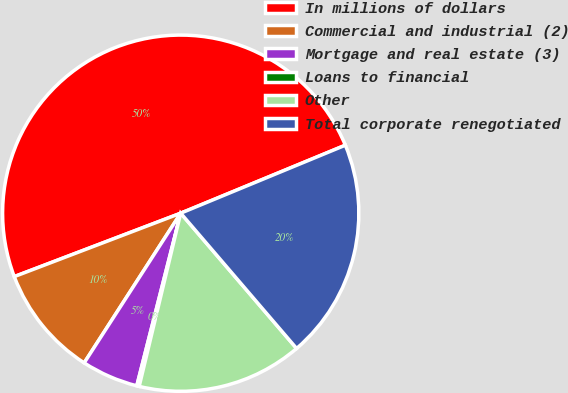Convert chart to OTSL. <chart><loc_0><loc_0><loc_500><loc_500><pie_chart><fcel>In millions of dollars<fcel>Commercial and industrial (2)<fcel>Mortgage and real estate (3)<fcel>Loans to financial<fcel>Other<fcel>Total corporate renegotiated<nl><fcel>49.56%<fcel>10.09%<fcel>5.15%<fcel>0.22%<fcel>15.02%<fcel>19.96%<nl></chart> 